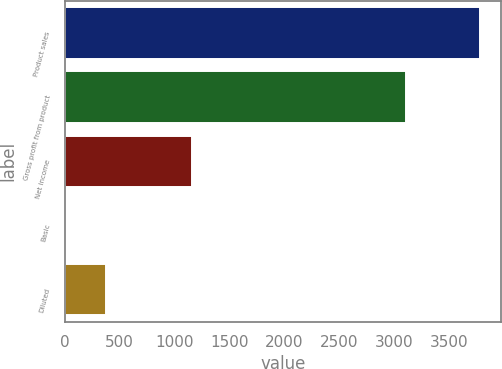Convert chart. <chart><loc_0><loc_0><loc_500><loc_500><bar_chart><fcel>Product sales<fcel>Gross profit from product<fcel>Net income<fcel>Basic<fcel>Diluted<nl><fcel>3784<fcel>3107<fcel>1158<fcel>1.09<fcel>379.38<nl></chart> 